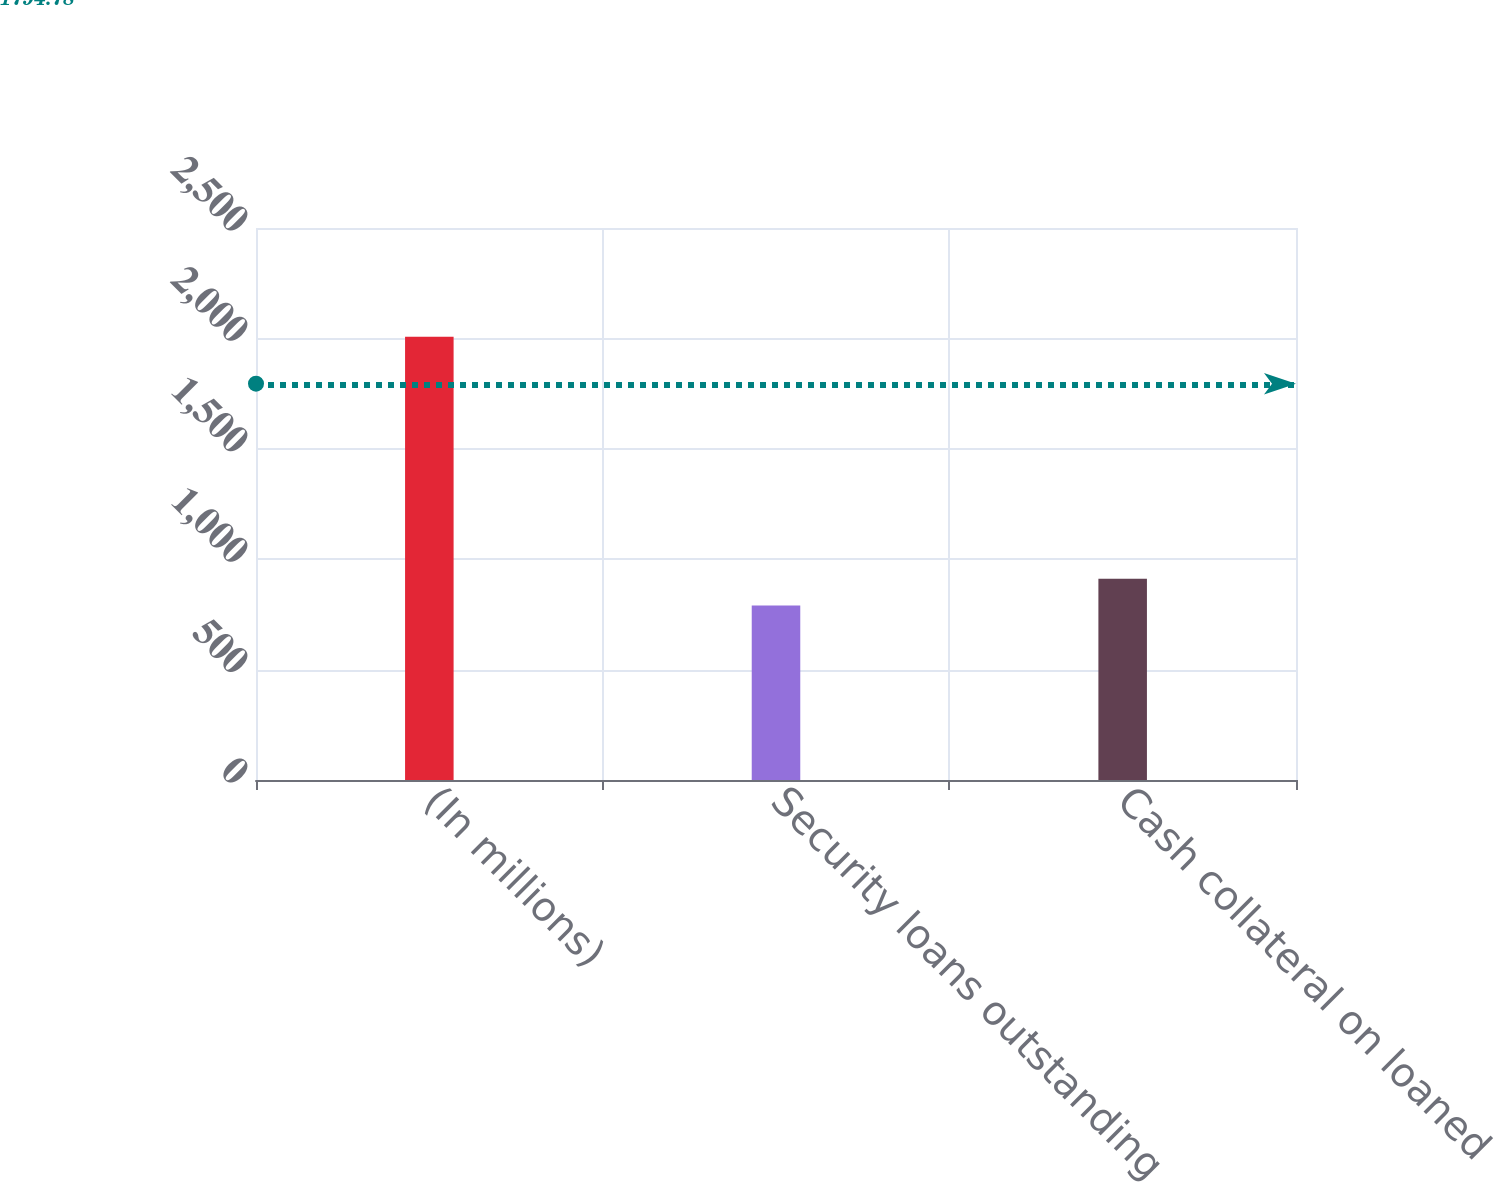<chart> <loc_0><loc_0><loc_500><loc_500><bar_chart><fcel>(In millions)<fcel>Security loans outstanding<fcel>Cash collateral on loaned<nl><fcel>2007<fcel>790<fcel>911.7<nl></chart> 